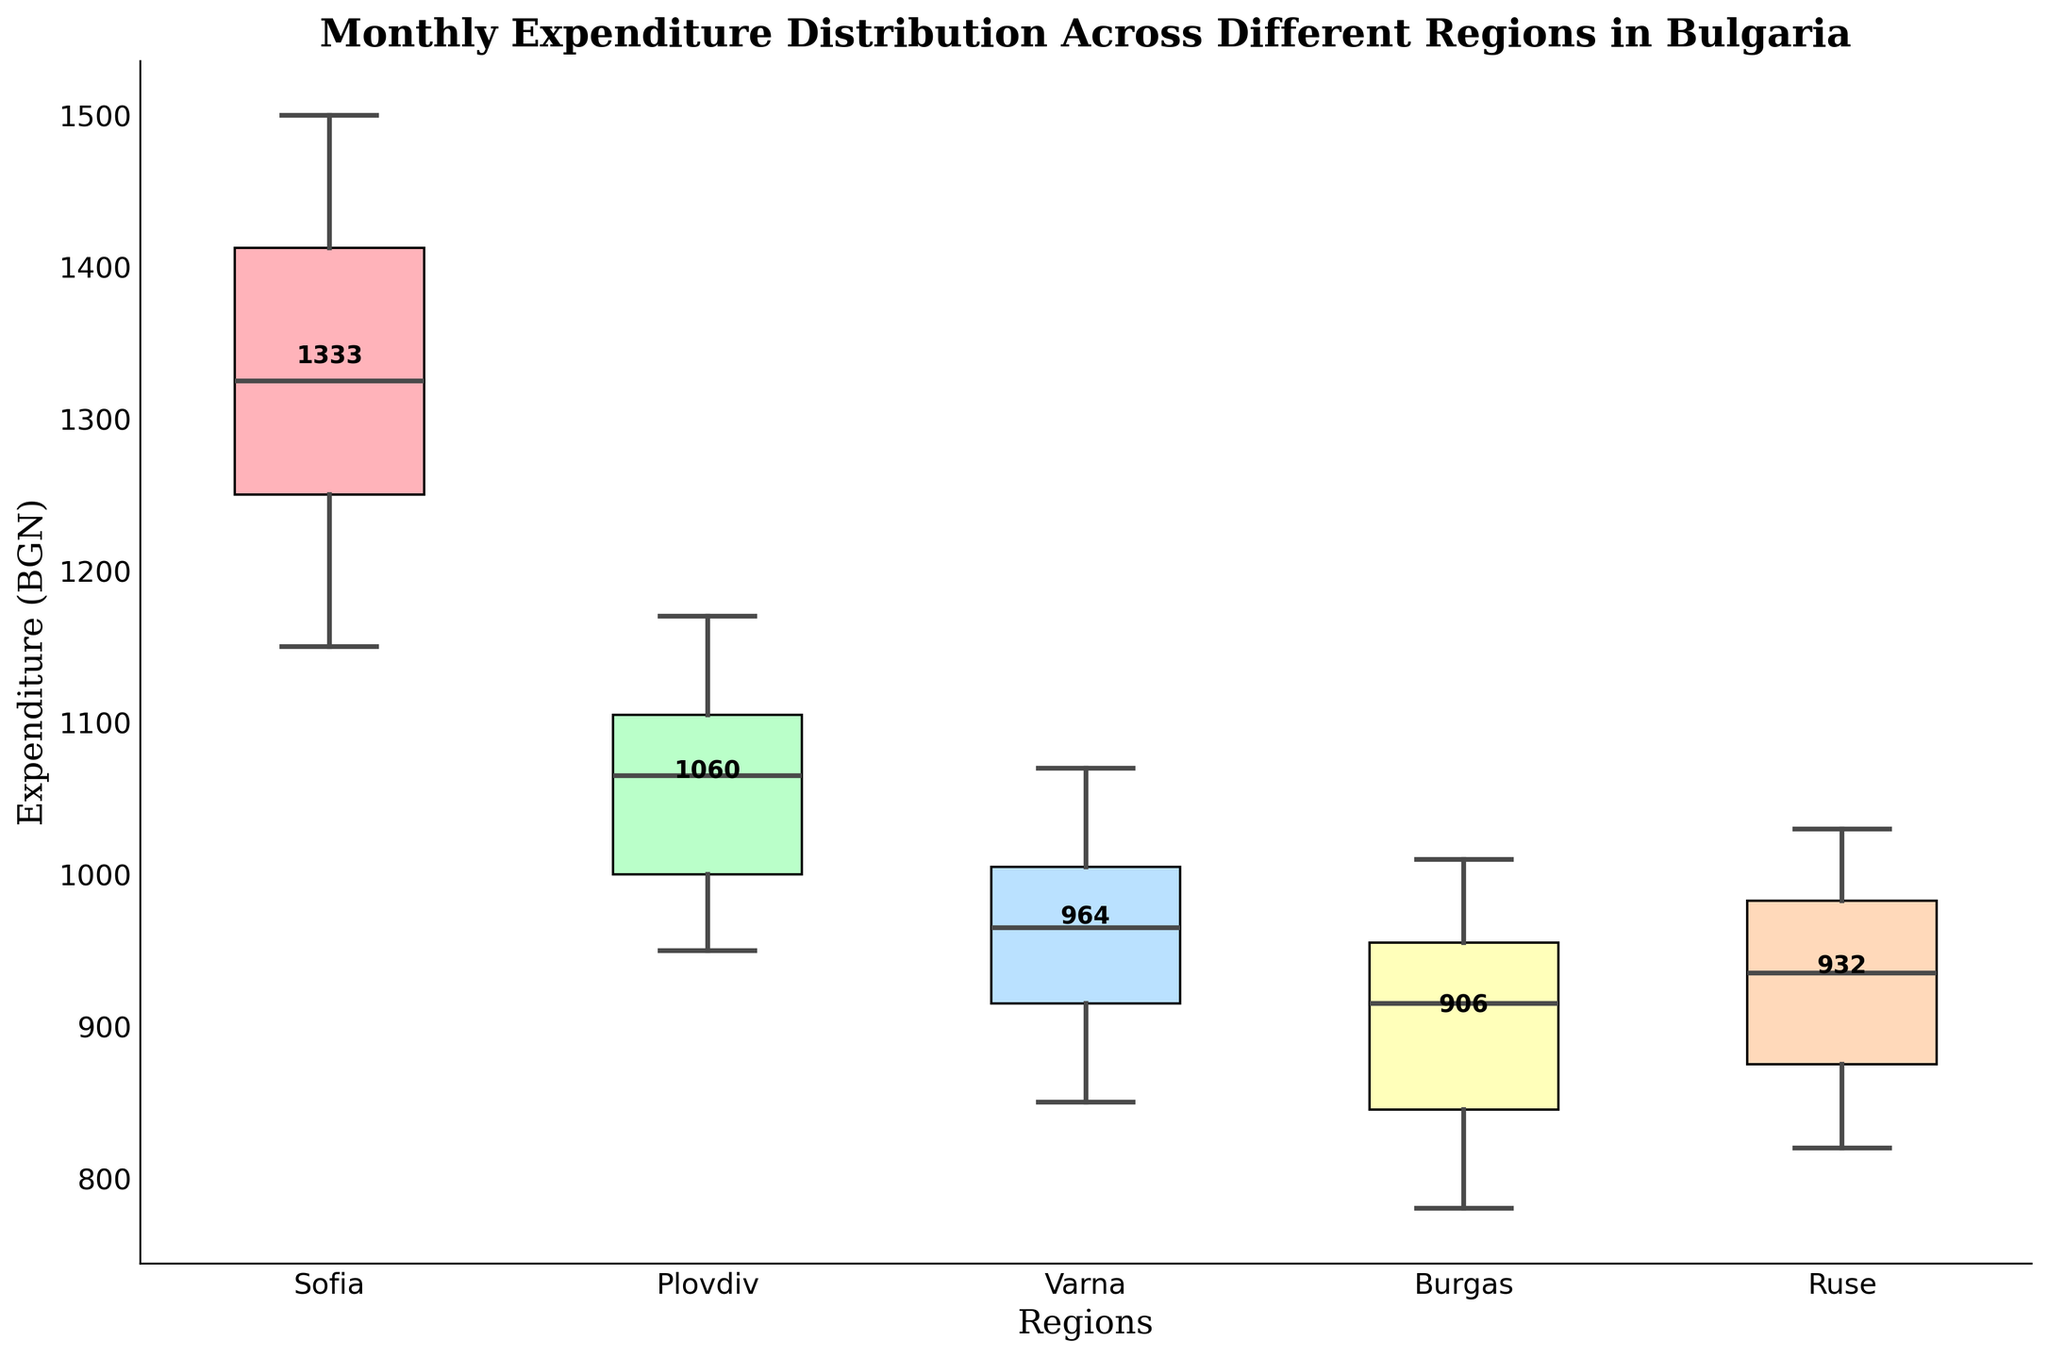What is the title of the chart? The title is located at the top of the chart and indicates the main topic of the figure.
Answer: Monthly Expenditure Distribution Across Different Regions in Bulgaria Which region has the highest median monthly expenditure? The median is represented by the line inside each box. The region with the highest median line is identifiable as the one at the highest vertical position.
Answer: Sofia What is the range of monthly expenditures in Sofia? The range is determined by the difference between the highest and lowest points (whiskers) of the Sofia box plot.
Answer: 1150 - 1500 Which region shows the lowest monthly expenditure and what is its value? The lowest value is represented by the lowest whisker in the box plots. Identify the region with the lowest whisker and note its value.
Answer: Burgas, 780 Compare the median monthly expenditure of Plovdiv and Varna. Which is higher? The median expenditure is shown by the line inside each box plot. Compare the medians of Plovdiv and Varna to see which is higher.
Answer: Plovdiv Which region has the most variability in monthly expenditures? Variability within a box plot can be observed by the Interquartile Range (IQR), which is the height of the box. Look for the region with the tallest box.
Answer: Sofia What is the mean monthly expenditure for Ruse? The mean for each region is noted as a number denoted near each respective box plot. Check the numerical label near Ruse.
Answer: 935 How do the monthly expenditures in Burgas compare to those in Sofia in terms of the median? Compare the line inside the Burgas box to the line inside the Sofia box, which represents the median monthly expenditure.
Answer: Sofia's median is higher What are the typical expenditures (interquartile range) in Varna? The interquartile range (IQR) is the height of the box. Identify the lower quartile (bottom of the box) and the upper quartile (top of the box) values for Varna.
Answer: 850 - 1070 Between which two regions is the difference in median monthly expenditure the smallest? Compare the median lines of each box plot to find the regions whose medians are closest in value.
Answer: Plovdiv and Ruse 